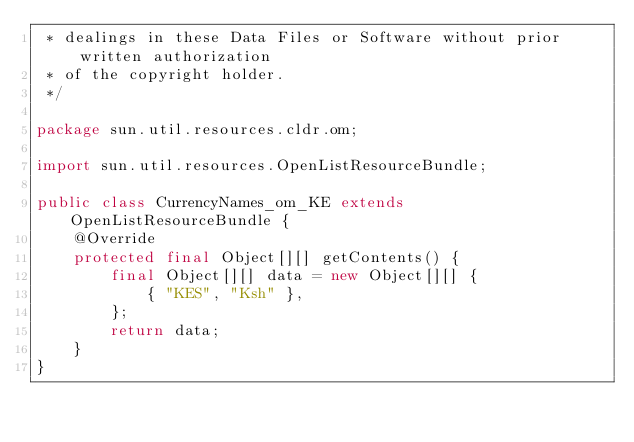Convert code to text. <code><loc_0><loc_0><loc_500><loc_500><_Java_> * dealings in these Data Files or Software without prior written authorization
 * of the copyright holder.
 */

package sun.util.resources.cldr.om;

import sun.util.resources.OpenListResourceBundle;

public class CurrencyNames_om_KE extends OpenListResourceBundle {
    @Override
    protected final Object[][] getContents() {
        final Object[][] data = new Object[][] {
            { "KES", "Ksh" },
        };
        return data;
    }
}
</code> 